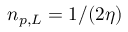Convert formula to latex. <formula><loc_0><loc_0><loc_500><loc_500>n _ { p , L } = 1 / ( 2 \eta )</formula> 